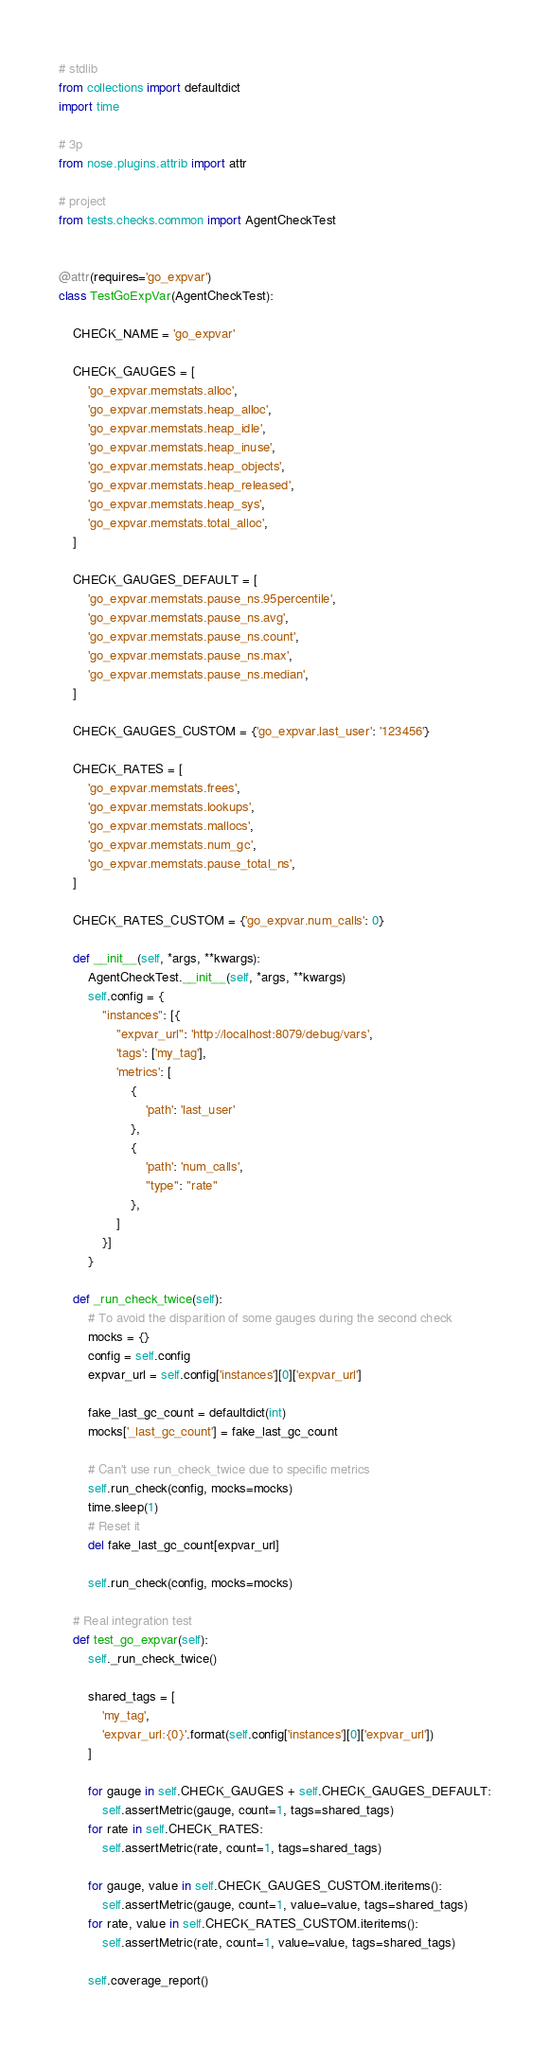<code> <loc_0><loc_0><loc_500><loc_500><_Python_># stdlib
from collections import defaultdict
import time

# 3p
from nose.plugins.attrib import attr

# project
from tests.checks.common import AgentCheckTest


@attr(requires='go_expvar')
class TestGoExpVar(AgentCheckTest):

    CHECK_NAME = 'go_expvar'

    CHECK_GAUGES = [
        'go_expvar.memstats.alloc',
        'go_expvar.memstats.heap_alloc',
        'go_expvar.memstats.heap_idle',
        'go_expvar.memstats.heap_inuse',
        'go_expvar.memstats.heap_objects',
        'go_expvar.memstats.heap_released',
        'go_expvar.memstats.heap_sys',
        'go_expvar.memstats.total_alloc',
    ]

    CHECK_GAUGES_DEFAULT = [
        'go_expvar.memstats.pause_ns.95percentile',
        'go_expvar.memstats.pause_ns.avg',
        'go_expvar.memstats.pause_ns.count',
        'go_expvar.memstats.pause_ns.max',
        'go_expvar.memstats.pause_ns.median',
    ]

    CHECK_GAUGES_CUSTOM = {'go_expvar.last_user': '123456'}

    CHECK_RATES = [
        'go_expvar.memstats.frees',
        'go_expvar.memstats.lookups',
        'go_expvar.memstats.mallocs',
        'go_expvar.memstats.num_gc',
        'go_expvar.memstats.pause_total_ns',
    ]

    CHECK_RATES_CUSTOM = {'go_expvar.num_calls': 0}

    def __init__(self, *args, **kwargs):
        AgentCheckTest.__init__(self, *args, **kwargs)
        self.config = {
            "instances": [{
                "expvar_url": 'http://localhost:8079/debug/vars',
                'tags': ['my_tag'],
                'metrics': [
                    {
                        'path': 'last_user'
                    },
                    {
                        'path': 'num_calls',
                        "type": "rate"
                    },
                ]
            }]
        }

    def _run_check_twice(self):
        # To avoid the disparition of some gauges during the second check
        mocks = {}
        config = self.config
        expvar_url = self.config['instances'][0]['expvar_url']

        fake_last_gc_count = defaultdict(int)
        mocks['_last_gc_count'] = fake_last_gc_count

        # Can't use run_check_twice due to specific metrics
        self.run_check(config, mocks=mocks)
        time.sleep(1)
        # Reset it
        del fake_last_gc_count[expvar_url]

        self.run_check(config, mocks=mocks)

    # Real integration test
    def test_go_expvar(self):
        self._run_check_twice()

        shared_tags = [
            'my_tag',
            'expvar_url:{0}'.format(self.config['instances'][0]['expvar_url'])
        ]

        for gauge in self.CHECK_GAUGES + self.CHECK_GAUGES_DEFAULT:
            self.assertMetric(gauge, count=1, tags=shared_tags)
        for rate in self.CHECK_RATES:
            self.assertMetric(rate, count=1, tags=shared_tags)

        for gauge, value in self.CHECK_GAUGES_CUSTOM.iteritems():
            self.assertMetric(gauge, count=1, value=value, tags=shared_tags)
        for rate, value in self.CHECK_RATES_CUSTOM.iteritems():
            self.assertMetric(rate, count=1, value=value, tags=shared_tags)

        self.coverage_report()
</code> 